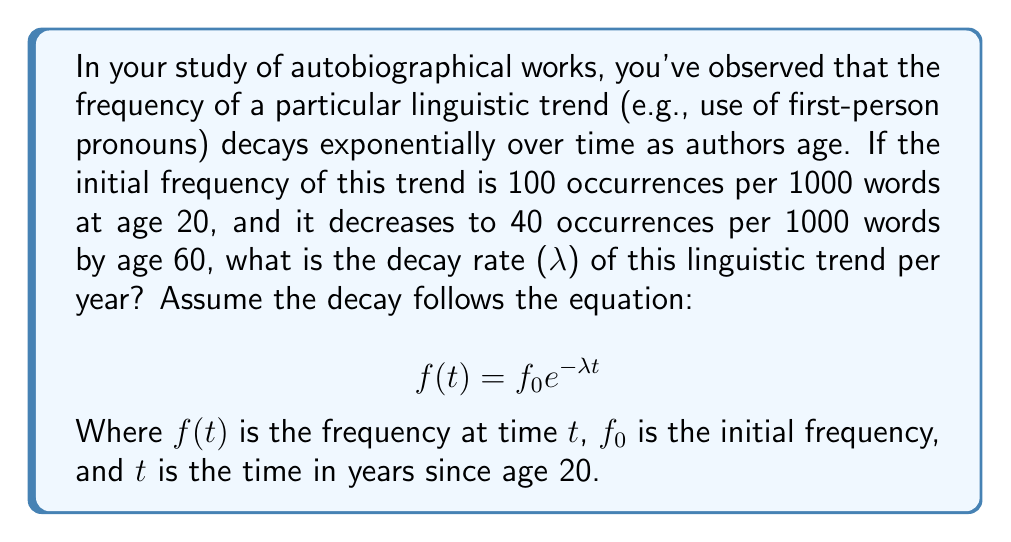Teach me how to tackle this problem. To solve this problem, we'll use the exponential decay equation and the given information:

1. Initial frequency $f_0 = 100$ occurrences per 1000 words at age 20
2. Final frequency $f(40) = 40$ occurrences per 1000 words at age 60 (40 years later)

Let's plug these values into the equation:

$$ 40 = 100 e^{-40\lambda} $$

Now, we'll solve for λ:

1. Divide both sides by 100:
   $$ \frac{40}{100} = e^{-40\lambda} $$

2. Take the natural logarithm of both sides:
   $$ \ln(\frac{40}{100}) = \ln(e^{-40\lambda}) $$
   $$ \ln(0.4) = -40\lambda $$

3. Solve for λ:
   $$ -40\lambda = \ln(0.4) $$
   $$ \lambda = -\frac{\ln(0.4)}{40} $$

4. Calculate the final value:
   $$ \lambda = -\frac{\ln(0.4)}{40} \approx 0.0229 $$

Therefore, the decay rate λ is approximately 0.0229 per year.
Answer: $\lambda \approx 0.0229$ per year 